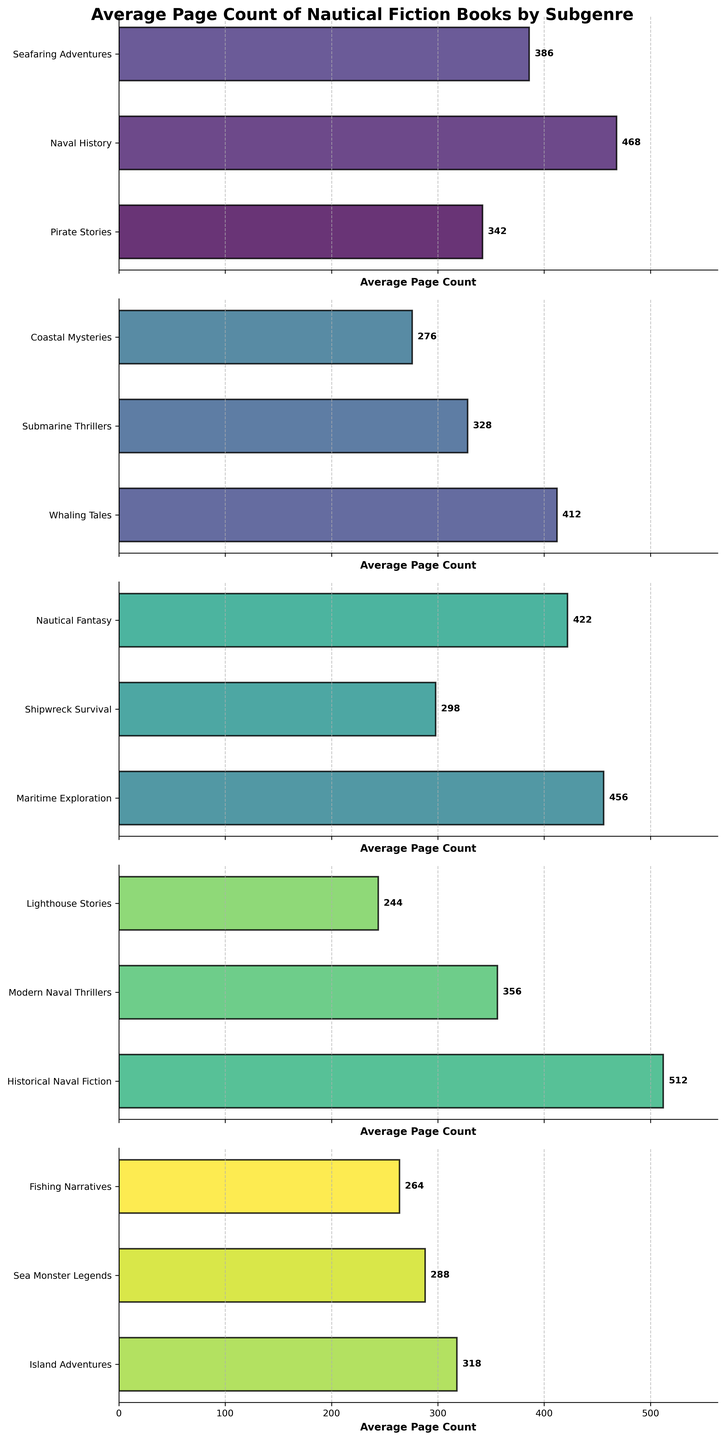Which subgenre has the highest average page count? To find the subgenre with the highest average page count, identify and compare the values for page count of all subgenres. Historical Naval Fiction has the highest bar with 512 pages.
Answer: Historical Naval Fiction Which subgenre is closest to an average of 400 pages? To find the subgenre closest to an average of 400 pages, look for the bar heights near 400. Whaling Tales at 412 pages and Nautical Fantasy at 422 pages are close, but Whaling Tales is the closest.
Answer: Whaling Tales How much less is the average page count of "Coastal Mysteries" than "Historical Naval Fiction"? Find the average page counts for both subgenres (276 for Coastal Mysteries and 512 for Historical Naval Fiction), then calculate the difference, 512 - 276 = 236.
Answer: 236 Which subgenre has a higher average page count: “Seafaring Adventures” or "Modern Naval Thrillers"? Compare the lengths of the bars for "Seafaring Adventures" (386) and "Modern Naval Thrillers" (356). Seafaring Adventures has a longer (higher) bar.
Answer: Seafaring Adventures Is "Fishing Narratives" shorter than 300 pages on average? Locate the bar for "Fishing Narratives" and see if it falls below the 300-page mark. It is at 264, which is less than 300.
Answer: Yes What is the combined average page count of "Pirate Stories," "Seafaring Adventures," and "Submarine Thrillers"? Add the average page counts for Pirate Stories (342), Seafaring Adventures (386), and Submarine Thrillers (328): 342 + 386 + 328 = 1056.
Answer: 1056 Which subgenre has a lower average page count: "Lighthouse Stories" or "Whaling Tales"? Compare the bars for Lighthouse Stories (244) and Whaling Tales (412). Lighthouse Stories is significantly lower.
Answer: Lighthouse Stories What is the difference in page count between "Naval History" and "Shipwreck Survival"? Identify "Naval History" (468) and "Shipwreck Survival" (298), and calculate the difference, 468 - 298 = 170.
Answer: 170 Which subgenre's average page count is closest to the middle of the range (between the shortest and longest books)? Identify the shortest (Lighthouse Stories at 244) and longest (Historical Naval Fiction at 512) average page counts. The middle of the range is (244+512)/2 = 378. Comparing, Seafaring Adventures at 386 is closest to this value.
Answer: Seafaring Adventures How many subgenres have an average page count over 400? Count the number of subgenres where the bars extend beyond the 400 mark. Observing closely, there are four: Naval History (468), Whaling Tales (412), Nautical Fantasy (422), and Historical Naval Fiction (512).
Answer: 4 